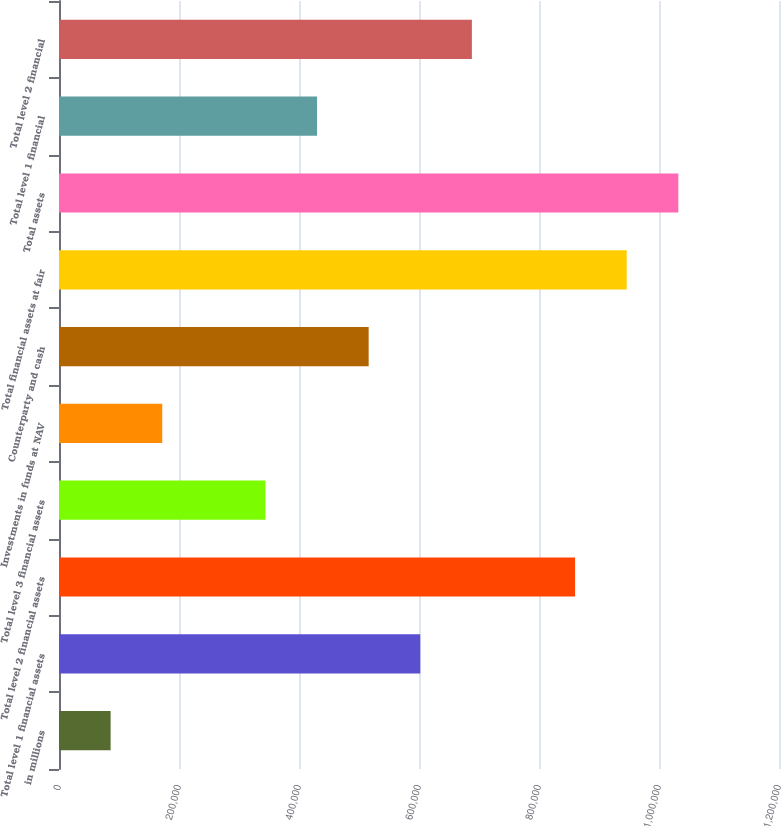<chart> <loc_0><loc_0><loc_500><loc_500><bar_chart><fcel>in millions<fcel>Total level 1 financial assets<fcel>Total level 2 financial assets<fcel>Total level 3 financial assets<fcel>Investments in funds at NAV<fcel>Counterparty and cash<fcel>Total financial assets at fair<fcel>Total assets<fcel>Total level 1 financial<fcel>Total level 2 financial<nl><fcel>86023.6<fcel>602118<fcel>860165<fcel>344071<fcel>172039<fcel>516102<fcel>946181<fcel>1.0322e+06<fcel>430086<fcel>688134<nl></chart> 